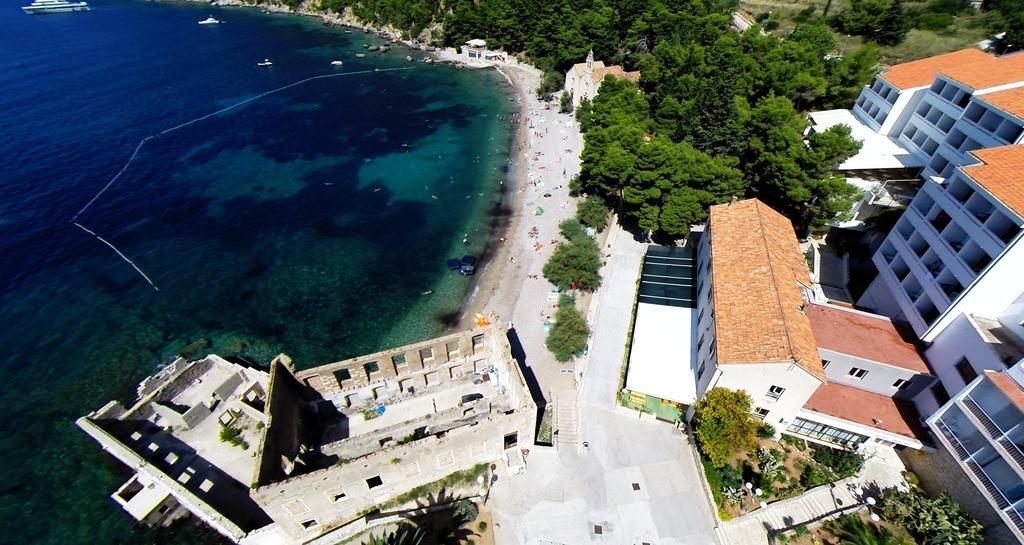How would you summarize this image in a sentence or two? To the right side of the image there are houses with windows, roofs and walls. There are many trees. And to the left side of the image there is an ocean with ships and to the seashore there are few items. And to the top of the image there are few trees. To the bottom left of the image there are buildings. 